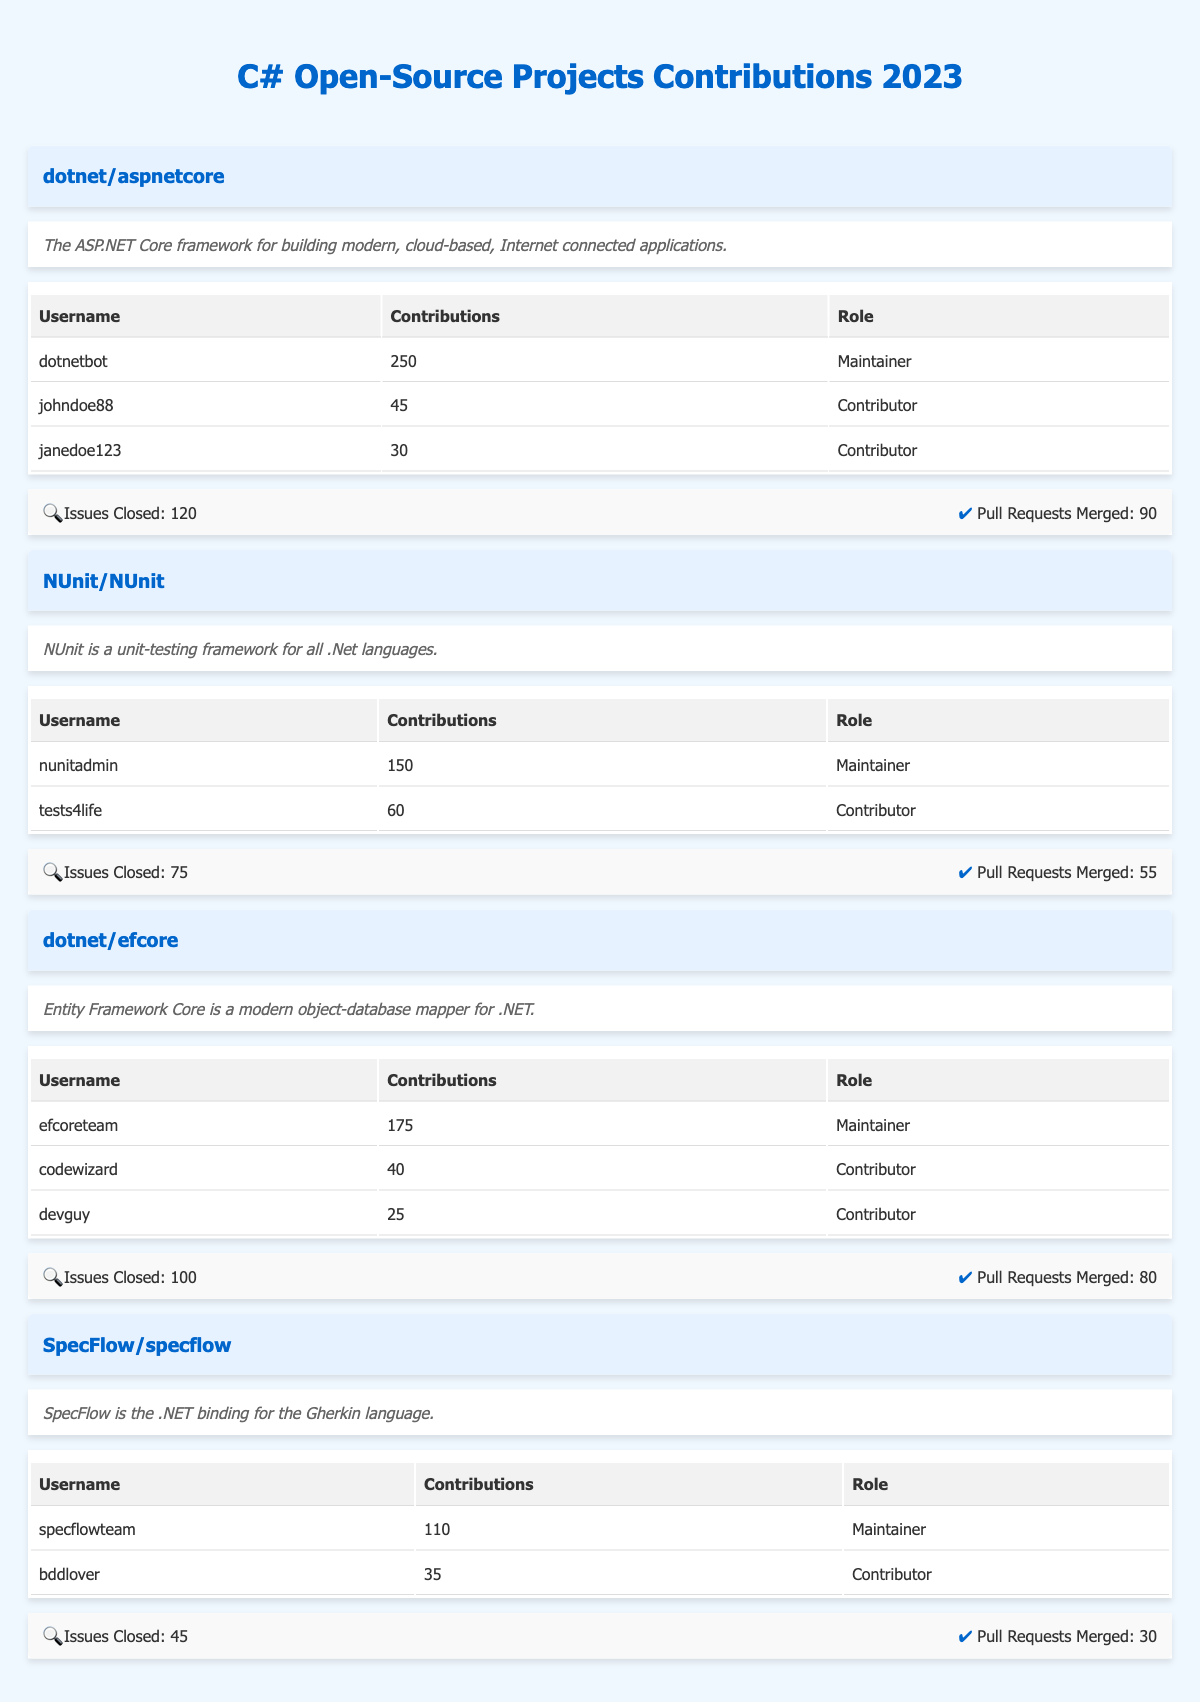What is the maximum number of contributions by a single contributor across all projects? The highest number of contributions can be found by comparing the contributions made by each contributor in the table. The top contributor is "dotnetbot" from "dotnet/aspnetcore" with 250 contributions.
Answer: 250 Which project has the least number of pull requests merged? By looking at the column "Pull Requests Merged," the following values are identified: 90 for "dotnet/aspnetcore," 55 for "NUnit/NUnit," 80 for "dotnet/efcore," and 30 for "SpecFlow/specflow." The project with the least merged pull requests is "SpecFlow/specflow" with 30.
Answer: SpecFlow/specflow How many total contributions were made by all contributors for "dotnet/efcore"? Adding the contributions of all contributors for "dotnet/efcore" gives: 175 (efcoreteam) + 40 (codewizard) + 25 (devguy) = 240 total contributions.
Answer: 240 Was there any project that had more issues closed than pull requests merged? Comparing "Issues Closed" and "Pull Requests Merged" for each project, "dotnet/aspnetcore" (120 issues closed, 90 PRs merged), "NUnit/NUnit" (75 closed, 55 merged), "dotnet/efcore" (100 closed, 80 merged), and "SpecFlow/specflow" (45 closed, 30 merged) indicates that all have more issues closed than pull requests merged. Therefore, the answer is yes.
Answer: Yes What is the average number of contributions per contributor for the "NUnit/NUnit" project? The total contributions for "NUnit/NUnit" are from two contributors: 150 (nunitadmin) + 60 (tests4life) = 210. There are 2 contributors, so the average contributions per contributor are 210 divided by 2, which gives 105.
Answer: 105 Which project has the highest number of issues closed, and how many were closed? Looking at the "Issues Closed" column, the projects have the following closed issues: "dotnet/aspnetcore" (120), "NUnit/NUnit" (75), "dotnet/efcore" (100), and "SpecFlow/specflow" (45). The project with the highest number of closed issues is "dotnet/aspnetcore" with 120 issues.
Answer: dotnet/aspnetcore, 120 How many contributors are there in total across all projects? Counting the total number of contributors in each project: "dotnet/aspnetcore" has 3, "NUnit/NUnit" has 2, "dotnet/efcore" has 3, and "SpecFlow/specflow" has 2. This totals to 3 + 2 + 3 + 2 = 10 contributors.
Answer: 10 Is "janedoe123" a maintainer for any project? "janedoe123" is listed under "dotnet/aspnetcore" as a Contributor, not as a Maintainer. Hence, the answer is no.
Answer: No 